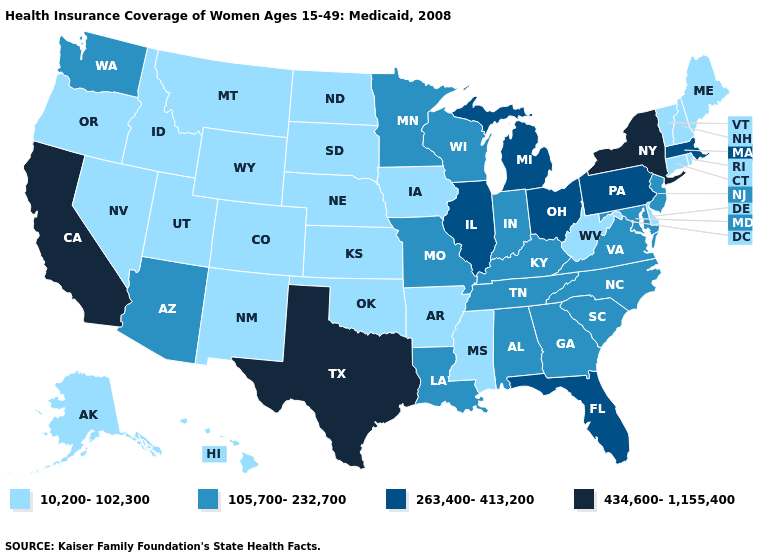What is the value of Ohio?
Keep it brief. 263,400-413,200. Name the states that have a value in the range 434,600-1,155,400?
Quick response, please. California, New York, Texas. Name the states that have a value in the range 10,200-102,300?
Short answer required. Alaska, Arkansas, Colorado, Connecticut, Delaware, Hawaii, Idaho, Iowa, Kansas, Maine, Mississippi, Montana, Nebraska, Nevada, New Hampshire, New Mexico, North Dakota, Oklahoma, Oregon, Rhode Island, South Dakota, Utah, Vermont, West Virginia, Wyoming. Does New York have the highest value in the Northeast?
Short answer required. Yes. Does Nevada have the lowest value in the West?
Short answer required. Yes. How many symbols are there in the legend?
Be succinct. 4. Does Mississippi have the same value as Arizona?
Be succinct. No. Which states have the highest value in the USA?
Be succinct. California, New York, Texas. What is the value of North Dakota?
Give a very brief answer. 10,200-102,300. What is the highest value in states that border Texas?
Short answer required. 105,700-232,700. What is the highest value in the South ?
Keep it brief. 434,600-1,155,400. Does Kentucky have the lowest value in the USA?
Be succinct. No. How many symbols are there in the legend?
Short answer required. 4. What is the lowest value in the USA?
Keep it brief. 10,200-102,300. What is the value of Illinois?
Write a very short answer. 263,400-413,200. 